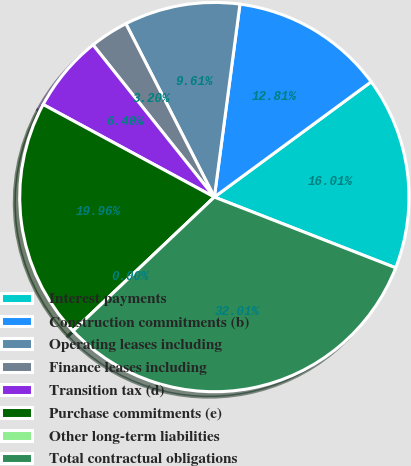Convert chart to OTSL. <chart><loc_0><loc_0><loc_500><loc_500><pie_chart><fcel>Interest payments<fcel>Construction commitments (b)<fcel>Operating leases including<fcel>Finance leases including<fcel>Transition tax (d)<fcel>Purchase commitments (e)<fcel>Other long-term liabilities<fcel>Total contractual obligations<nl><fcel>16.01%<fcel>12.81%<fcel>9.61%<fcel>3.2%<fcel>6.4%<fcel>19.96%<fcel>0.0%<fcel>32.01%<nl></chart> 